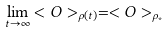<formula> <loc_0><loc_0><loc_500><loc_500>\lim _ { t \rightarrow \infty } < O > _ { \rho ( t ) } = < O > _ { \rho _ { * } }</formula> 